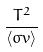Convert formula to latex. <formula><loc_0><loc_0><loc_500><loc_500>\frac { T ^ { 2 } } { \langle \sigma v \rangle }</formula> 